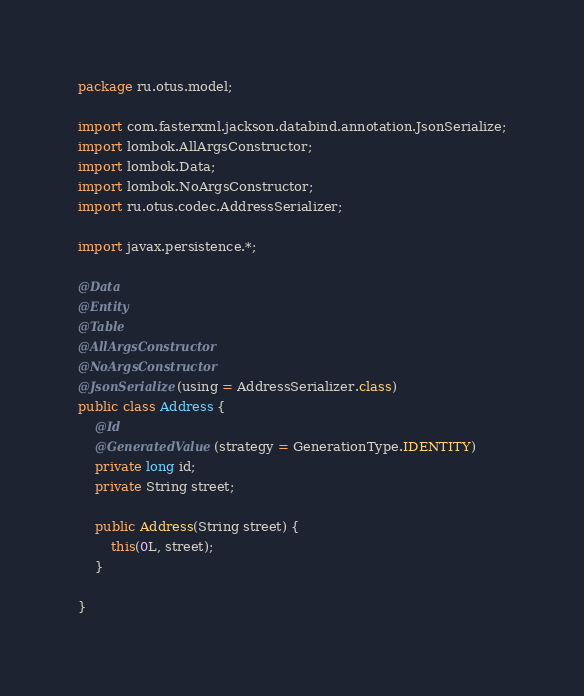Convert code to text. <code><loc_0><loc_0><loc_500><loc_500><_Java_>package ru.otus.model;

import com.fasterxml.jackson.databind.annotation.JsonSerialize;
import lombok.AllArgsConstructor;
import lombok.Data;
import lombok.NoArgsConstructor;
import ru.otus.codec.AddressSerializer;

import javax.persistence.*;

@Data
@Entity
@Table
@AllArgsConstructor
@NoArgsConstructor
@JsonSerialize(using = AddressSerializer.class)
public class Address {
    @Id
    @GeneratedValue(strategy = GenerationType.IDENTITY)
    private long id;
    private String street;

    public Address(String street) {
        this(0L, street);
    }

}
</code> 